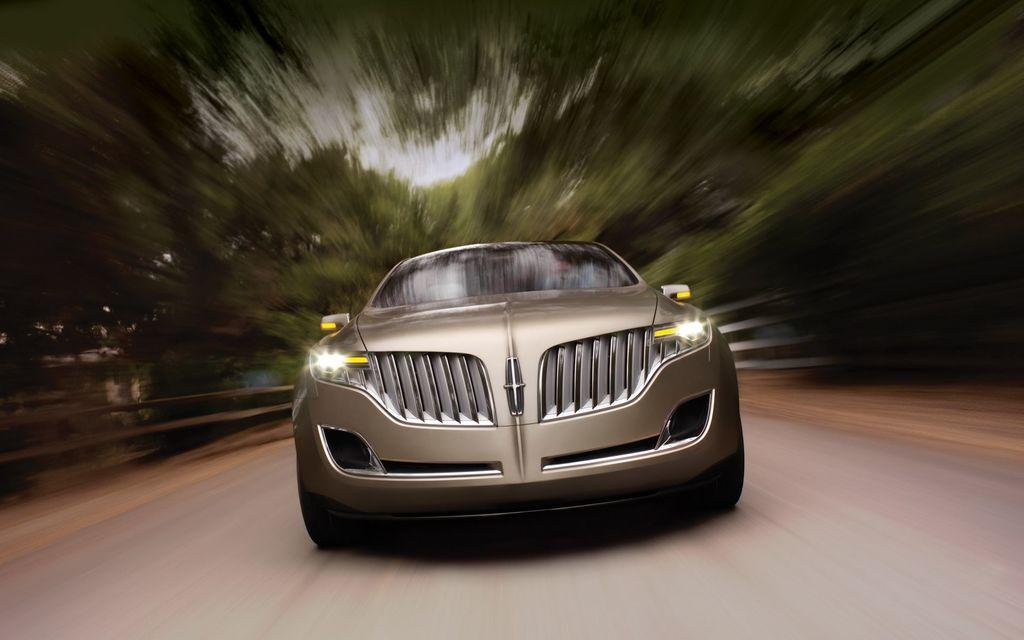What is the main subject of the image? The main subject of the image is a car. Where is the car located in the image? The car is on the road in the image. What can be seen in the background of the image? There is greenery visible in the background of the image. Can you tell me how many twigs are lying on the road next to the car in the image? There is no mention of twigs in the image, so it is not possible to determine how many might be lying on the road. What discovery was made by the driver of the car in the image? There is no indication in the image of any discovery made by the driver of the car. 